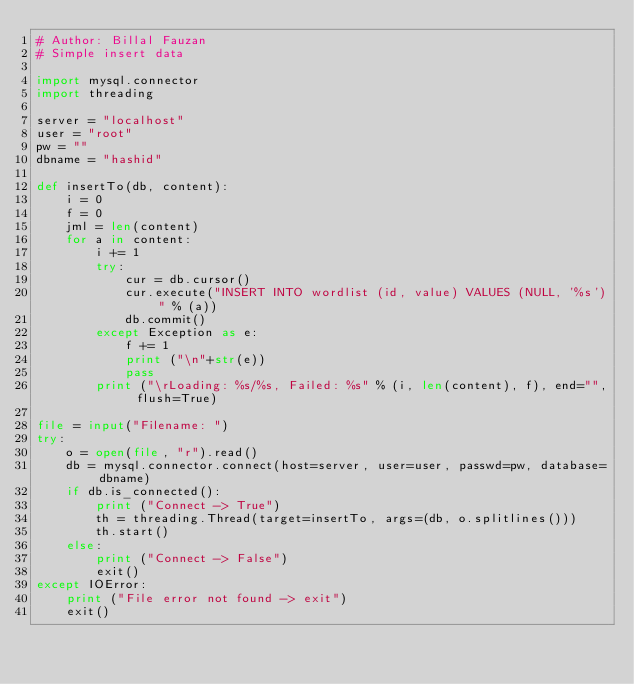Convert code to text. <code><loc_0><loc_0><loc_500><loc_500><_Python_># Author: Billal Fauzan
# Simple insert data

import mysql.connector
import threading

server = "localhost"
user = "root"
pw = ""
dbname = "hashid"

def insertTo(db, content):
	i = 0
	f = 0
	jml = len(content)
	for a in content:
		i += 1
		try:
			cur = db.cursor()
			cur.execute("INSERT INTO wordlist (id, value) VALUES (NULL, '%s')" % (a))
			db.commit()
		except Exception as e:
			f += 1
			print ("\n"+str(e))
			pass
		print ("\rLoading: %s/%s, Failed: %s" % (i, len(content), f), end="", flush=True)

file = input("Filename: ")
try:
	o = open(file, "r").read()
	db = mysql.connector.connect(host=server, user=user, passwd=pw, database=dbname)
	if db.is_connected():
		print ("Connect -> True")
		th = threading.Thread(target=insertTo, args=(db, o.splitlines()))
		th.start()
	else:
		print ("Connect -> False")
		exit()
except IOError:
	print ("File error not found -> exit")
	exit()

</code> 